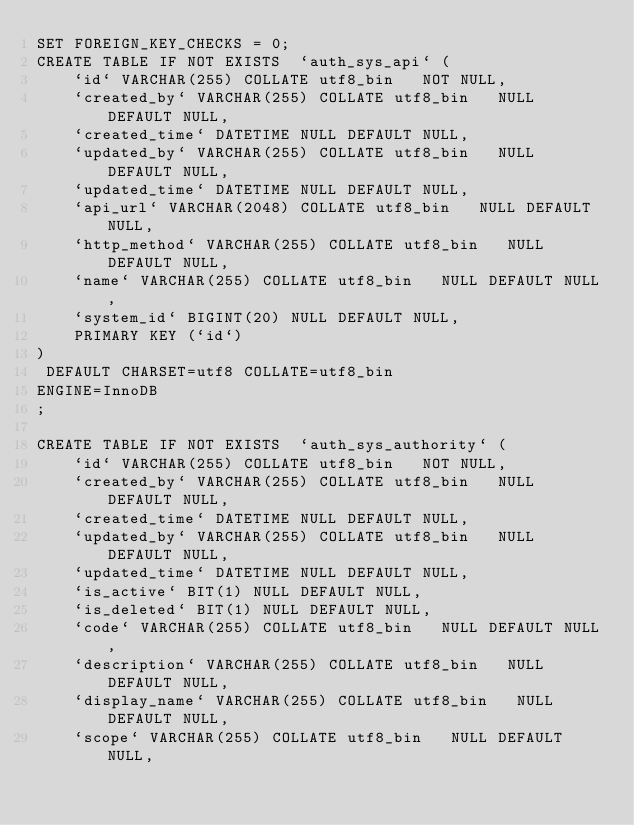<code> <loc_0><loc_0><loc_500><loc_500><_SQL_>SET FOREIGN_KEY_CHECKS = 0;
CREATE TABLE IF NOT EXISTS  `auth_sys_api` (
    `id` VARCHAR(255) COLLATE utf8_bin   NOT NULL,
    `created_by` VARCHAR(255) COLLATE utf8_bin   NULL DEFAULT NULL,
    `created_time` DATETIME NULL DEFAULT NULL,
    `updated_by` VARCHAR(255) COLLATE utf8_bin   NULL DEFAULT NULL,
    `updated_time` DATETIME NULL DEFAULT NULL,
    `api_url` VARCHAR(2048) COLLATE utf8_bin   NULL DEFAULT NULL,
    `http_method` VARCHAR(255) COLLATE utf8_bin   NULL DEFAULT NULL,
    `name` VARCHAR(255) COLLATE utf8_bin   NULL DEFAULT NULL,
    `system_id` BIGINT(20) NULL DEFAULT NULL,
    PRIMARY KEY (`id`)
)
 DEFAULT CHARSET=utf8 COLLATE=utf8_bin 
ENGINE=InnoDB
;

CREATE TABLE IF NOT EXISTS  `auth_sys_authority` (
    `id` VARCHAR(255) COLLATE utf8_bin   NOT NULL,
    `created_by` VARCHAR(255) COLLATE utf8_bin   NULL DEFAULT NULL,
    `created_time` DATETIME NULL DEFAULT NULL,
    `updated_by` VARCHAR(255) COLLATE utf8_bin   NULL DEFAULT NULL,
    `updated_time` DATETIME NULL DEFAULT NULL,
    `is_active` BIT(1) NULL DEFAULT NULL,
    `is_deleted` BIT(1) NULL DEFAULT NULL,
    `code` VARCHAR(255) COLLATE utf8_bin   NULL DEFAULT NULL,
    `description` VARCHAR(255) COLLATE utf8_bin   NULL DEFAULT NULL,
    `display_name` VARCHAR(255) COLLATE utf8_bin   NULL DEFAULT NULL,
    `scope` VARCHAR(255) COLLATE utf8_bin   NULL DEFAULT NULL,</code> 